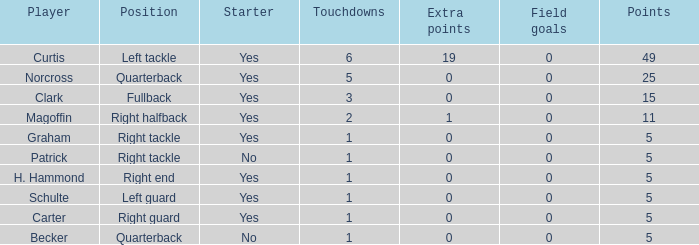Name the least touchdowns for 11 points 2.0. 